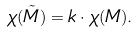<formula> <loc_0><loc_0><loc_500><loc_500>\chi ( \tilde { M } ) = k \cdot \chi ( M ) .</formula> 